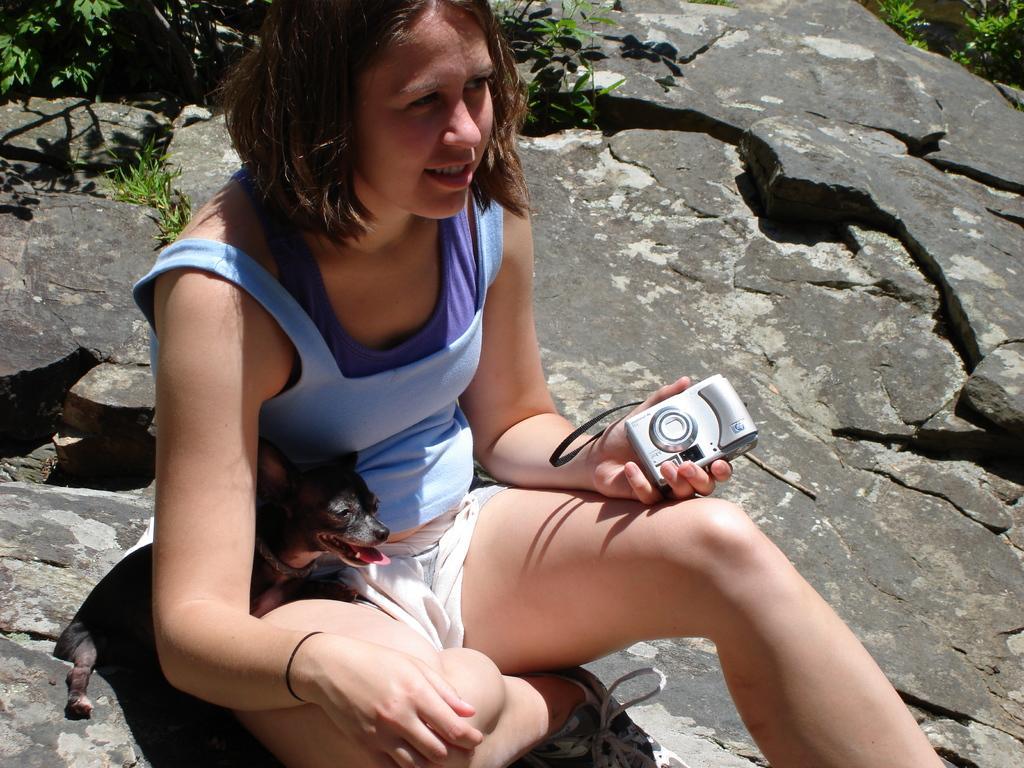How would you summarize this image in a sentence or two? In this picture there is a woman sitting, beside her there is a dog. This woman is holding a camera. She is sitting over a rock. There are plants in the background. This woman is wearing a blue t-shirt. 